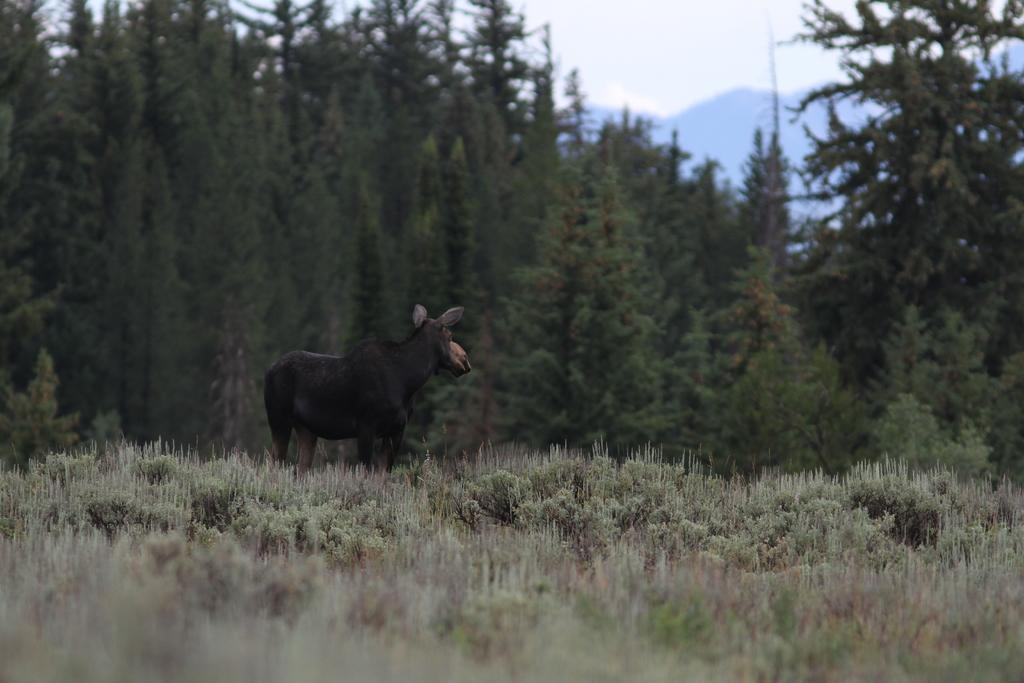What is the main subject in the center of the image? There is an animal in the center of the image. What can be seen in the background of the image? There are trees in the background of the image. What is present at the bottom of the image? There are plants at the bottom of the image. What is visible at the top of the image? There is sky visible at the top of the image. What type of landscape feature can be seen in the image? There are hills visible in the image. What type of cup is the farmer holding while talking to his brother in the image? There is no farmer, cup, or brother present in the image. 